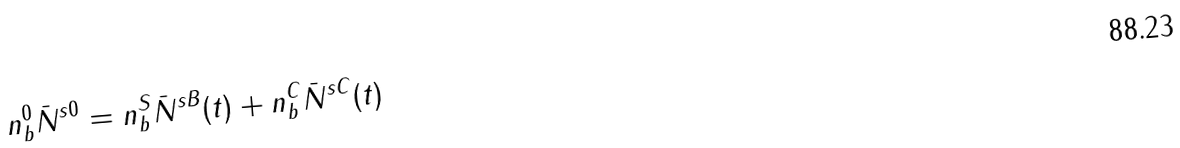<formula> <loc_0><loc_0><loc_500><loc_500>n ^ { 0 } _ { b } \bar { N } ^ { s 0 } = n ^ { S } _ { b } \bar { N } ^ { s B } ( t ) + n ^ { C } _ { b } \bar { N } ^ { s C } ( t )</formula> 